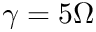<formula> <loc_0><loc_0><loc_500><loc_500>\gamma = 5 \Omega</formula> 